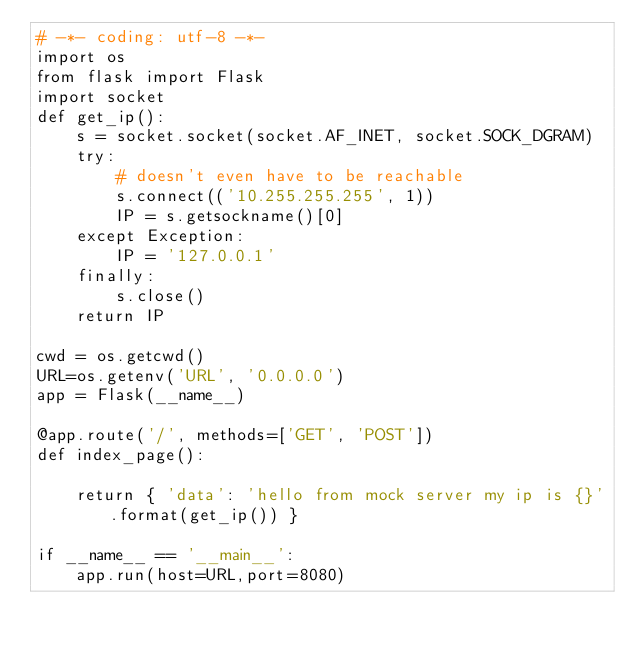<code> <loc_0><loc_0><loc_500><loc_500><_Python_># -*- coding: utf-8 -*-
import os
from flask import Flask
import socket
def get_ip():
    s = socket.socket(socket.AF_INET, socket.SOCK_DGRAM)
    try:
        # doesn't even have to be reachable
        s.connect(('10.255.255.255', 1))
        IP = s.getsockname()[0]
    except Exception:
        IP = '127.0.0.1'
    finally:
        s.close()
    return IP

cwd = os.getcwd()
URL=os.getenv('URL', '0.0.0.0')
app = Flask(__name__)

@app.route('/', methods=['GET', 'POST'])
def index_page():
    
    return { 'data': 'hello from mock server my ip is {}'.format(get_ip()) }

if __name__ == '__main__':
    app.run(host=URL,port=8080)</code> 